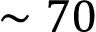Convert formula to latex. <formula><loc_0><loc_0><loc_500><loc_500>\sim 7 0</formula> 